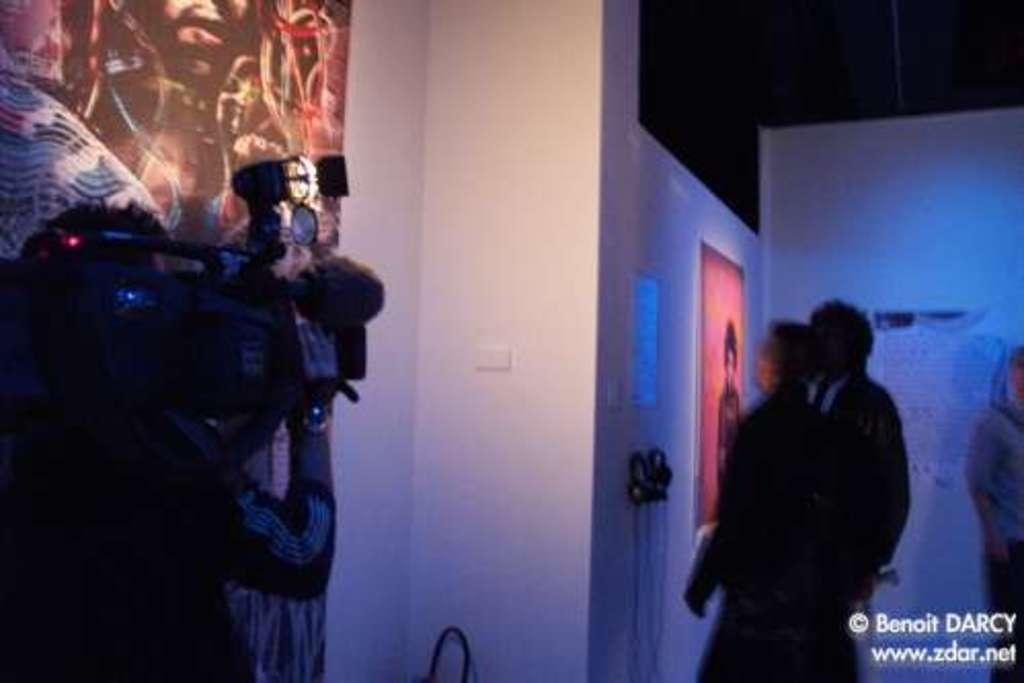Please provide a concise description of this image. This picture seems to be clicked the inside the hall. On the left we can see a person standing and holding a camera. On the right we can see the group of people and we can see the text and the pictures of some objects and the picture of a person on the wall and we can see some other objects. In the bottom right corner we can see the watermark on the image. 